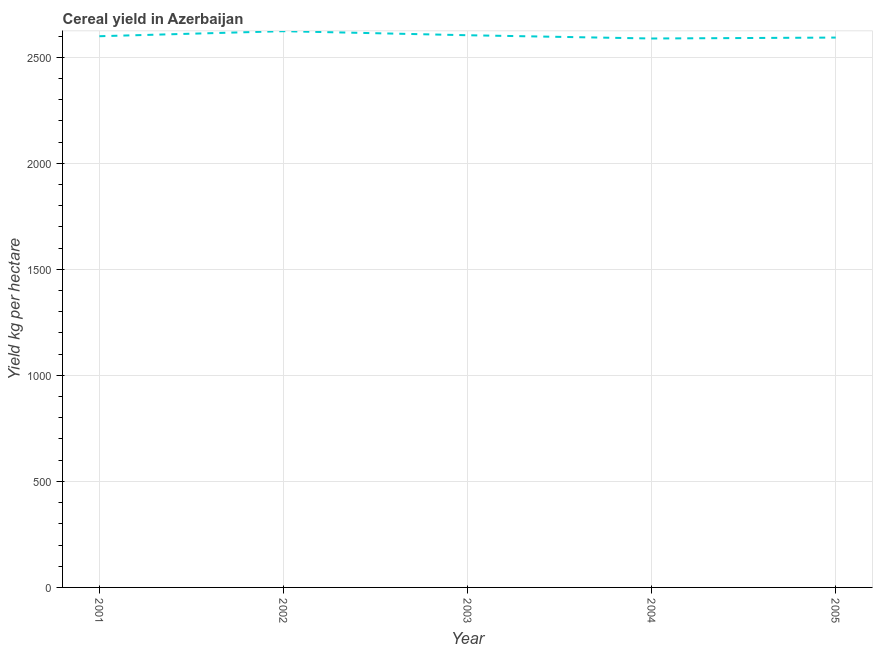What is the cereal yield in 2002?
Keep it short and to the point. 2623.23. Across all years, what is the maximum cereal yield?
Your answer should be very brief. 2623.23. Across all years, what is the minimum cereal yield?
Offer a very short reply. 2588.77. What is the sum of the cereal yield?
Give a very brief answer. 1.30e+04. What is the difference between the cereal yield in 2001 and 2003?
Keep it short and to the point. -4.6. What is the average cereal yield per year?
Keep it short and to the point. 2601.76. What is the median cereal yield?
Keep it short and to the point. 2599.55. In how many years, is the cereal yield greater than 500 kg per hectare?
Your response must be concise. 5. Do a majority of the years between 2001 and 2005 (inclusive) have cereal yield greater than 700 kg per hectare?
Offer a very short reply. Yes. What is the ratio of the cereal yield in 2004 to that in 2005?
Give a very brief answer. 1. What is the difference between the highest and the second highest cereal yield?
Offer a terse response. 19.08. Is the sum of the cereal yield in 2001 and 2005 greater than the maximum cereal yield across all years?
Your answer should be very brief. Yes. What is the difference between the highest and the lowest cereal yield?
Provide a succinct answer. 34.45. Does the cereal yield monotonically increase over the years?
Provide a succinct answer. No. How many lines are there?
Ensure brevity in your answer.  1. How many years are there in the graph?
Your answer should be very brief. 5. What is the difference between two consecutive major ticks on the Y-axis?
Your answer should be compact. 500. Does the graph contain any zero values?
Keep it short and to the point. No. Does the graph contain grids?
Make the answer very short. Yes. What is the title of the graph?
Your response must be concise. Cereal yield in Azerbaijan. What is the label or title of the Y-axis?
Make the answer very short. Yield kg per hectare. What is the Yield kg per hectare in 2001?
Provide a succinct answer. 2599.55. What is the Yield kg per hectare of 2002?
Ensure brevity in your answer.  2623.23. What is the Yield kg per hectare in 2003?
Your answer should be compact. 2604.15. What is the Yield kg per hectare of 2004?
Provide a short and direct response. 2588.77. What is the Yield kg per hectare in 2005?
Ensure brevity in your answer.  2593.13. What is the difference between the Yield kg per hectare in 2001 and 2002?
Provide a short and direct response. -23.68. What is the difference between the Yield kg per hectare in 2001 and 2003?
Offer a very short reply. -4.6. What is the difference between the Yield kg per hectare in 2001 and 2004?
Keep it short and to the point. 10.77. What is the difference between the Yield kg per hectare in 2001 and 2005?
Make the answer very short. 6.41. What is the difference between the Yield kg per hectare in 2002 and 2003?
Your response must be concise. 19.08. What is the difference between the Yield kg per hectare in 2002 and 2004?
Your response must be concise. 34.45. What is the difference between the Yield kg per hectare in 2002 and 2005?
Provide a short and direct response. 30.09. What is the difference between the Yield kg per hectare in 2003 and 2004?
Your answer should be very brief. 15.37. What is the difference between the Yield kg per hectare in 2003 and 2005?
Provide a short and direct response. 11.01. What is the difference between the Yield kg per hectare in 2004 and 2005?
Your answer should be very brief. -4.36. What is the ratio of the Yield kg per hectare in 2001 to that in 2002?
Offer a very short reply. 0.99. What is the ratio of the Yield kg per hectare in 2002 to that in 2004?
Keep it short and to the point. 1.01. What is the ratio of the Yield kg per hectare in 2003 to that in 2005?
Your answer should be compact. 1. 